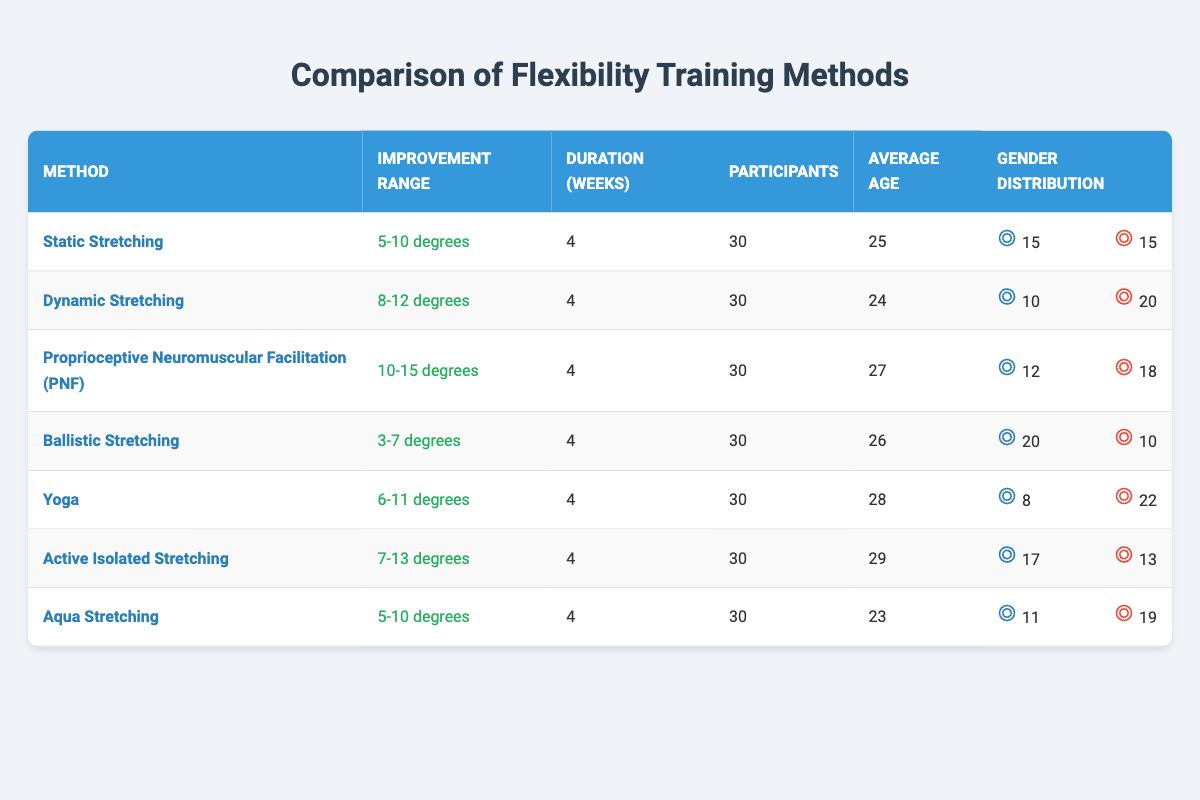What is the improvement range of Proprioceptive Neuromuscular Facilitation (PNF)? The table directly states that the improvement range for Proprioceptive Neuromuscular Facilitation (PNF) is 10-15 degrees.
Answer: 10-15 degrees How many male participants were involved in the Dynamic Stretching method? The gender distribution for Dynamic Stretching shows that there were 10 male participants.
Answer: 10 Which flexibility training method resulted in the highest average improvement range? By comparing the improvement ranges listed for all the methods, Proprioceptive Neuromuscular Facilitation (PNF) has the highest range of 10-15 degrees, surpassing the others.
Answer: Proprioceptive Neuromuscular Facilitation (PNF) What is the total number of female participants across all methods? To find the total number of female participants, we add the female participants from each method: 15 (Static) + 20 (Dynamic) + 18 (PNF) + 10 (Ballistic) + 22 (Yoga) + 13 (Active Isolated) + 19 (Aqua) = 127.
Answer: 127 Is the average age of participants in Ballistic Stretching higher than in Aqua Stretching? The average age for Ballistic Stretching is 26, and for Aqua Stretching, it is 23. Since 26 is greater than 23, the statement is true.
Answer: Yes What is the average improvement range of Static Stretching and Yoga? The improvement range for Static Stretching is 5-10 degrees and for Yoga is 6-11 degrees. To find the average range: (5+10)/2 = 7.5 degrees for Static Stretching and (6+11)/2 = 8.5 degrees for Yoga. These values are summed and divided by 2, leading to an average improvement of (7.5 + 8.5)/2 = 8 degrees overall for these two methods.
Answer: 8 degrees Which training method has the lowest average age of participants? By reviewing the average ages from the table, Static Stretching (25 years) has the lowest average age compared to the other methods (Dynamic 24, PNF 27, Ballistic 26, Yoga 28, Active Isolated 29, Aqua 23).
Answer: Dynamic Stretching (24 years) How many total participants were engaged in all training methods combined? Since each method had 30 participants and there are seven methods, we multiply 30 by 7 to find the total number of participants: 30 * 7 = 210.
Answer: 210 Does Yoga have a higher number of participants than Ballistic Stretching? Looking at the participant count, both methods had 30 participants, so the statement is false as they are equal.
Answer: No 